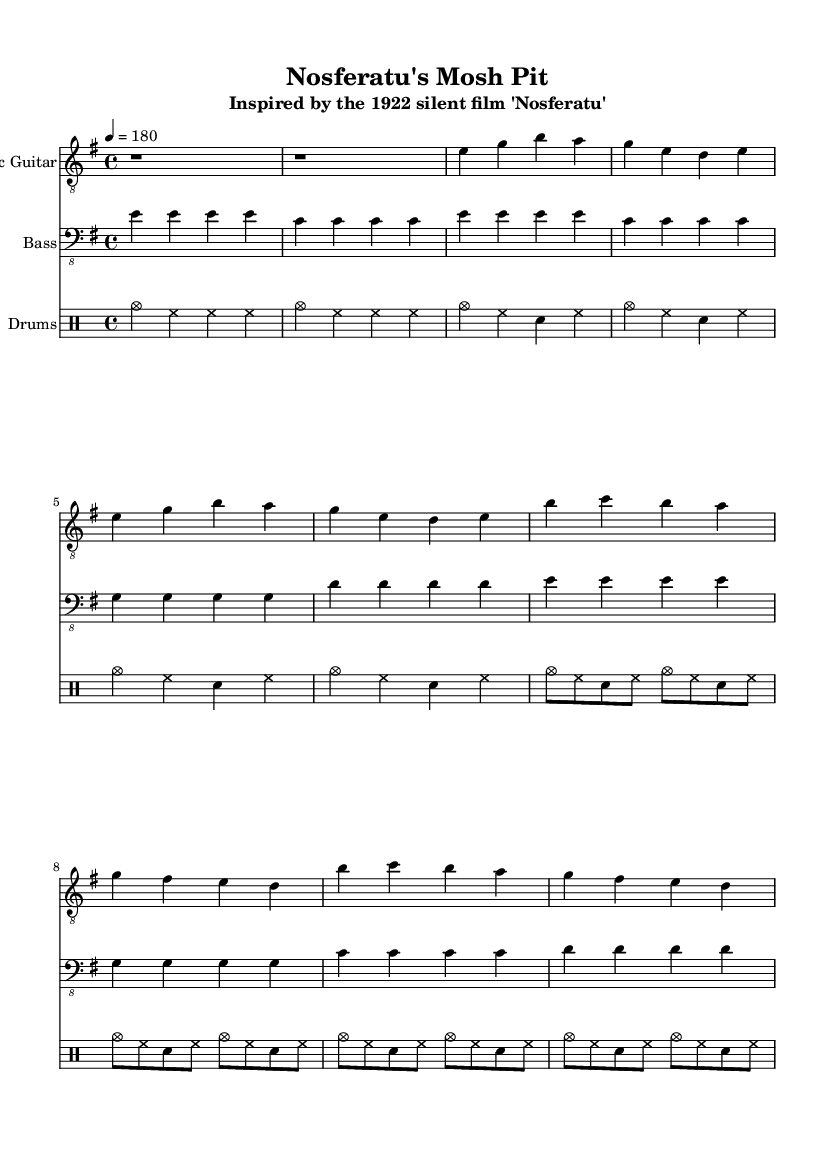What is the key signature of this music? The key signature of the music is indicated in the global section as E minor, which has one sharp (F#).
Answer: E minor What is the time signature of this music? The time signature is shown in the global section as 4/4, meaning there are four beats per measure and the quarter note gets one beat.
Answer: 4/4 What is the tempo marking for this music? The tempo is specified in the global section as 4 = 180, indicating that there are 180 beats per minute with a quarter note.
Answer: 180 How many measures does the verse consist of? The verse section of the electric guitar contains two sets of four beats, which equals 8 measures in total.
Answer: 8 measures How does the instrumentation reflect punk music characteristics? The instrumentation includes electric guitar, bass, and drums, which are typical elements in punk music, supporting driving rhythms and power chords to create energy and intensity.
Answer: Electric guitar, bass, drums What is the primary theme of the lyrics in relation to the silent film character? The lyrics reflect the themes of fear and intrigue associated with Count Orlok from "Nosferatu," evoking feelings of dread and the supernatural.
Answer: Count Orlok, dread 